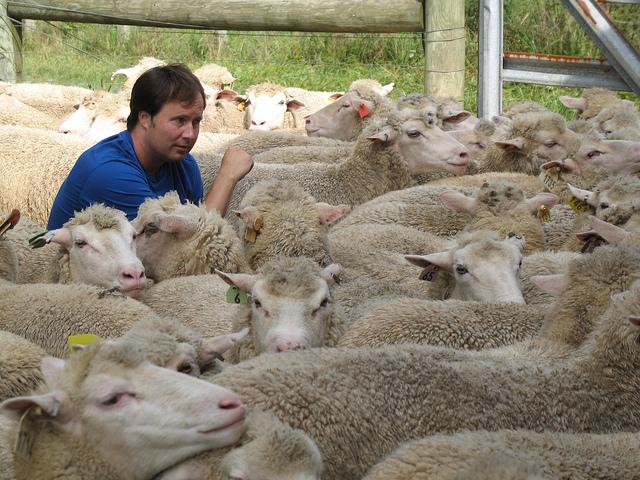What color is the man wearing?
Keep it brief. Blue. Are these goats?
Answer briefly. No. Do you think he is going to smell afterwards?
Give a very brief answer. Yes. 